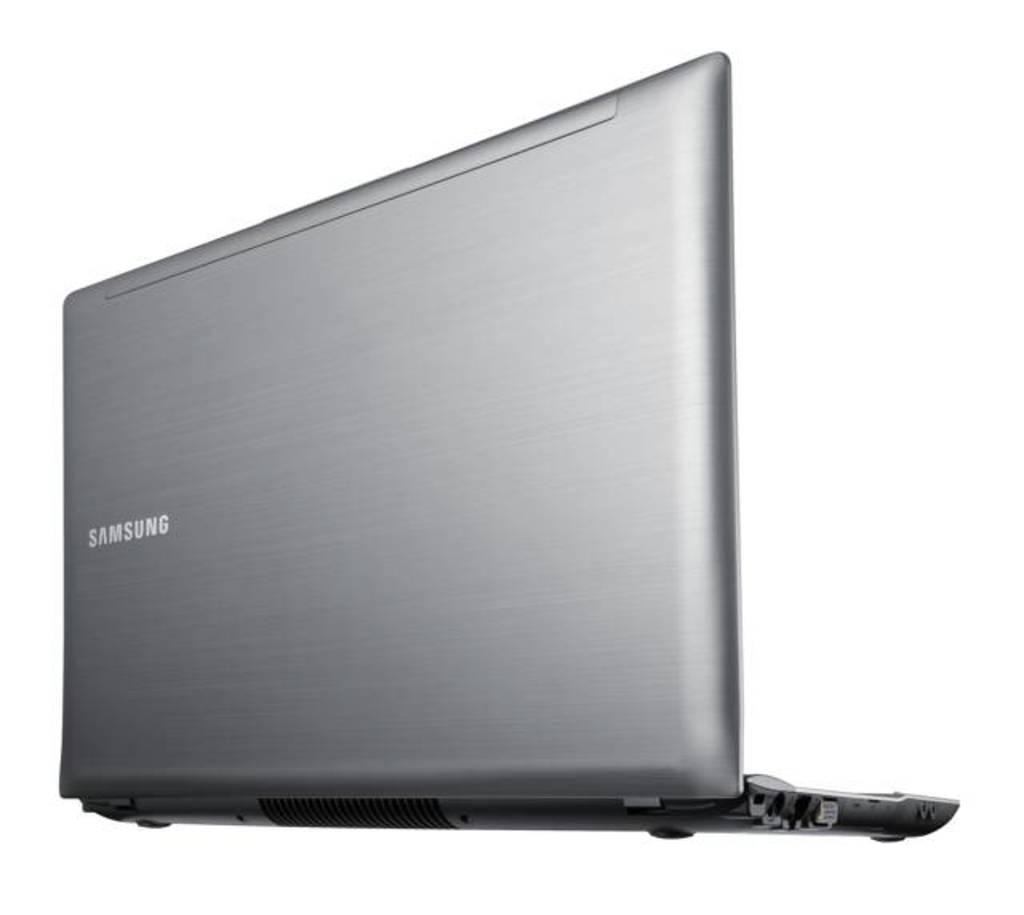<image>
Summarize the visual content of the image. The back end of a grey Samsung opened laptop. 